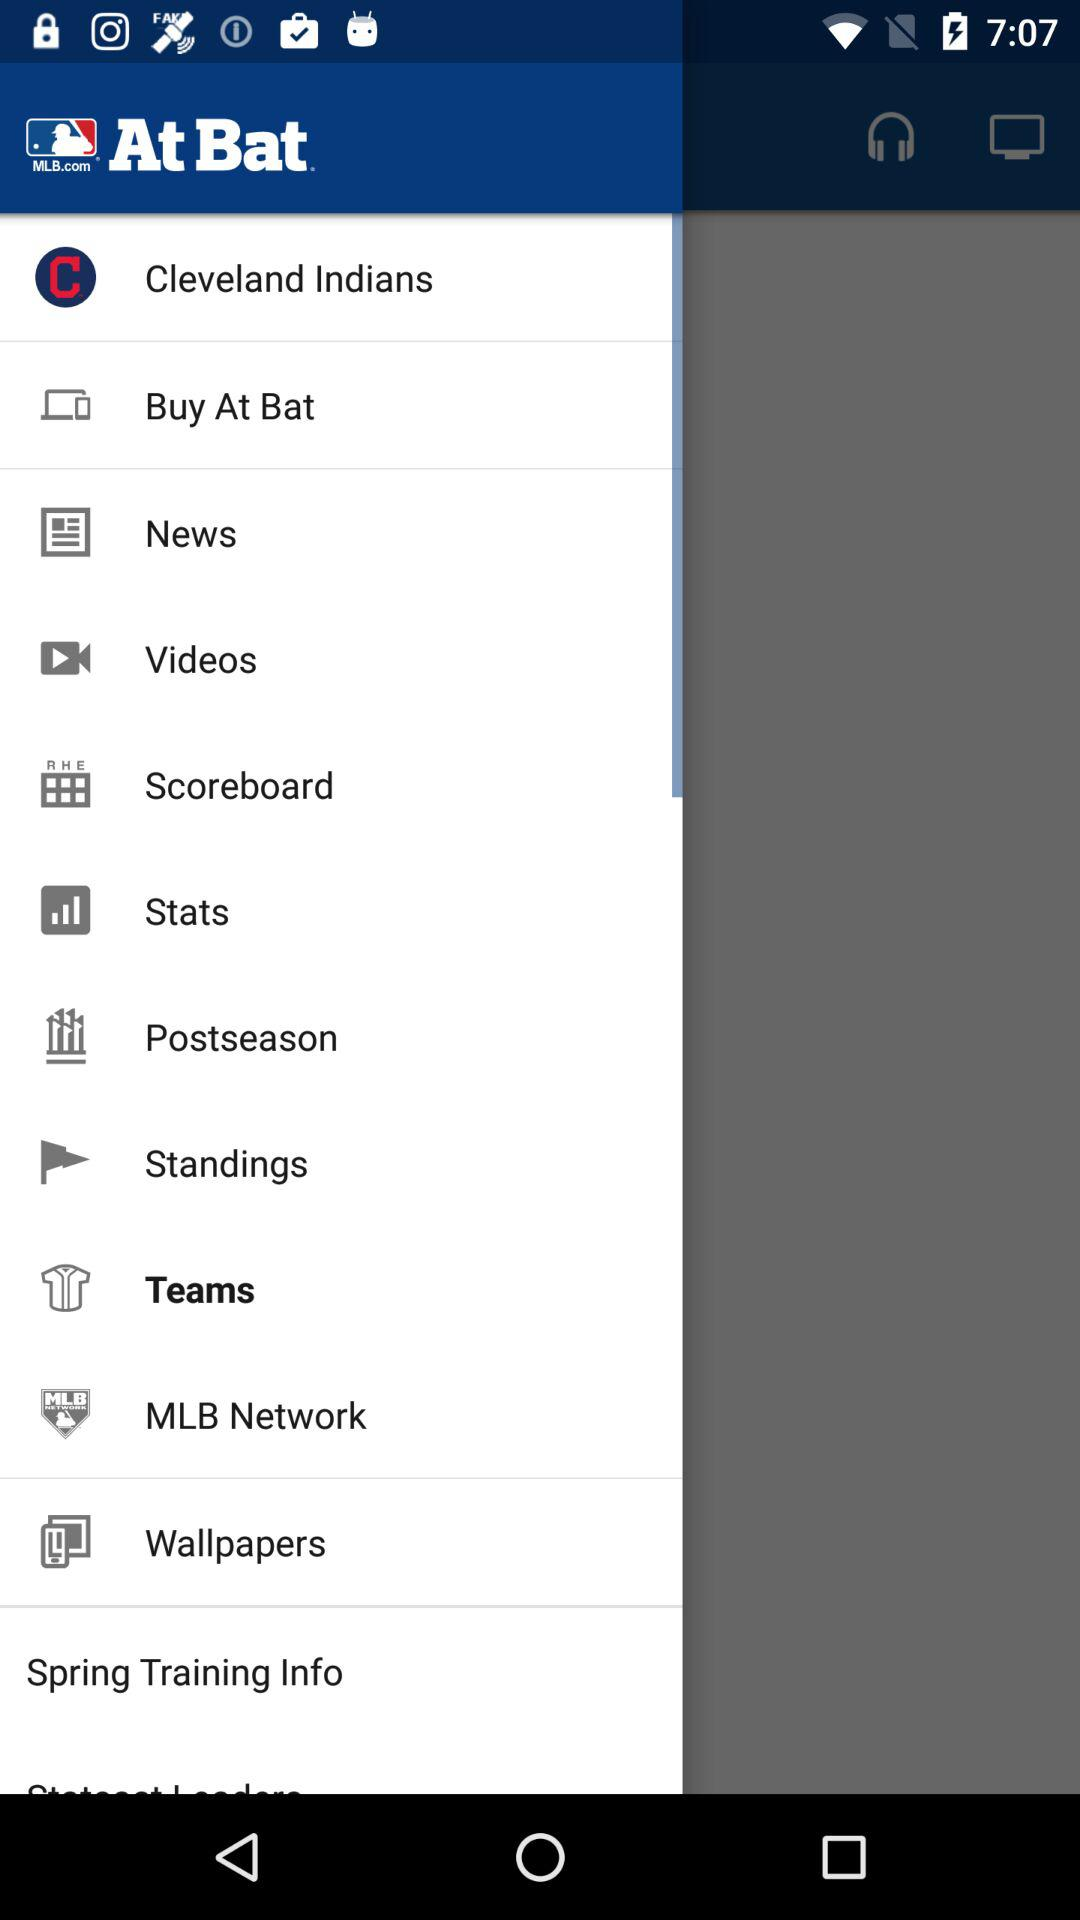What's the selected menu item? The selected item is "Teams". 